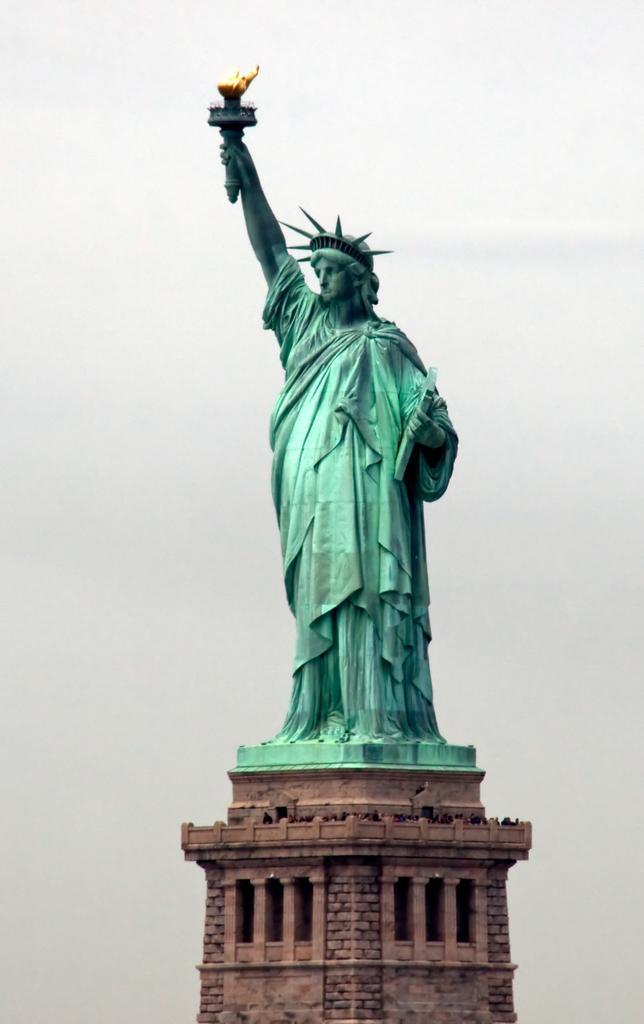Describe this image in one or two sentences. In this image I see the statue of liberty over here and I see the sky in the background. 